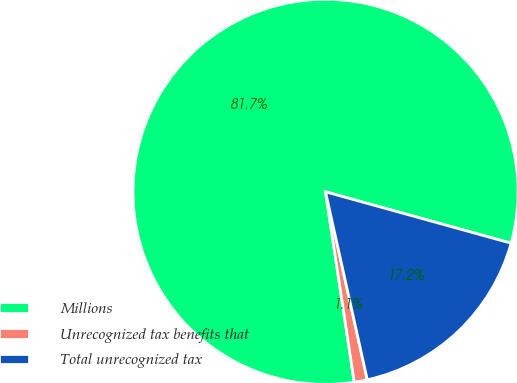Convert chart. <chart><loc_0><loc_0><loc_500><loc_500><pie_chart><fcel>Millions<fcel>Unrecognized tax benefits that<fcel>Total unrecognized tax<nl><fcel>81.69%<fcel>1.1%<fcel>17.22%<nl></chart> 